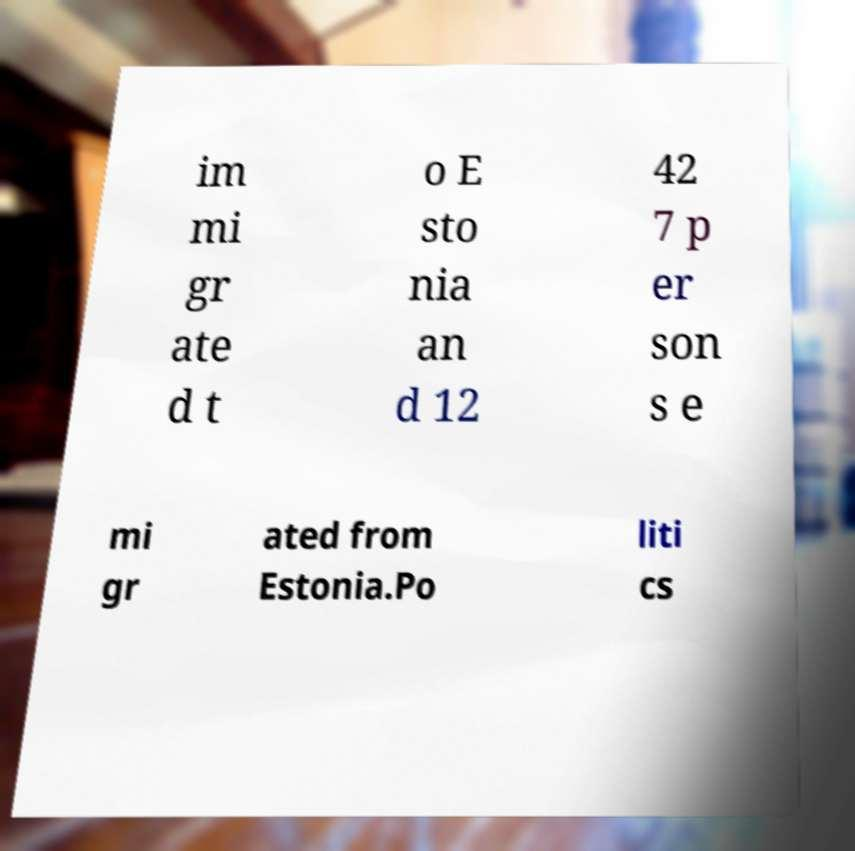Can you read and provide the text displayed in the image?This photo seems to have some interesting text. Can you extract and type it out for me? im mi gr ate d t o E sto nia an d 12 42 7 p er son s e mi gr ated from Estonia.Po liti cs 